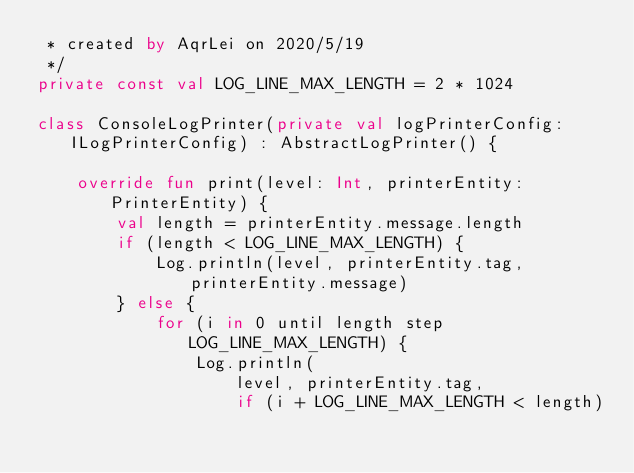Convert code to text. <code><loc_0><loc_0><loc_500><loc_500><_Kotlin_> * created by AqrLei on 2020/5/19
 */
private const val LOG_LINE_MAX_LENGTH = 2 * 1024

class ConsoleLogPrinter(private val logPrinterConfig: ILogPrinterConfig) : AbstractLogPrinter() {

    override fun print(level: Int, printerEntity: PrinterEntity) {
        val length = printerEntity.message.length
        if (length < LOG_LINE_MAX_LENGTH) {
            Log.println(level, printerEntity.tag, printerEntity.message)
        } else {
            for (i in 0 until length step LOG_LINE_MAX_LENGTH) {
                Log.println(
                    level, printerEntity.tag,
                    if (i + LOG_LINE_MAX_LENGTH < length)</code> 